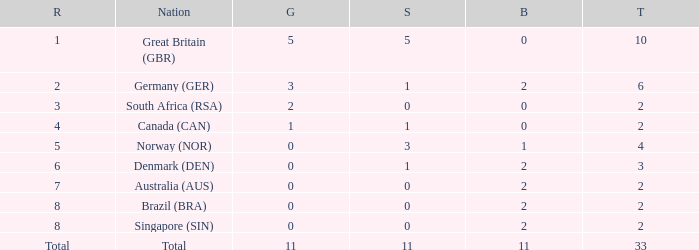What is the total when the nation is brazil (bra) and bronze is more than 2? None. 